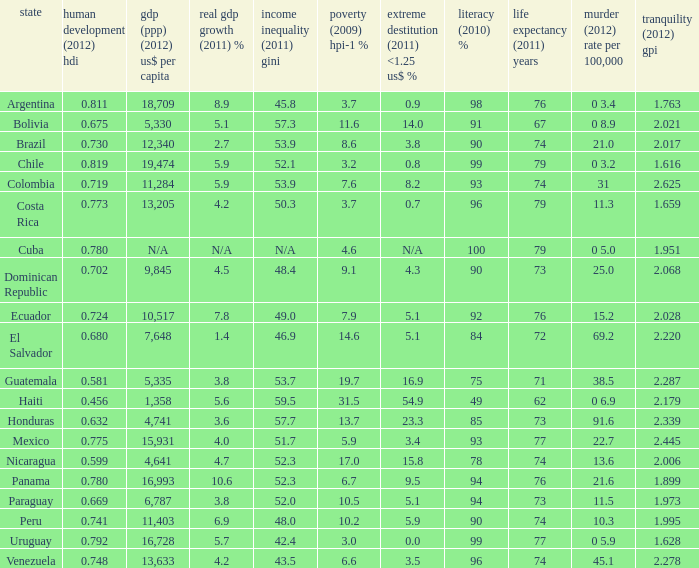What murder (2012) rate per 100,00 also has a 1.616 as the peace (2012) GPI? 0 3.2. 